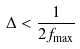<formula> <loc_0><loc_0><loc_500><loc_500>\Delta < \frac { 1 } { 2 f _ { \max } }</formula> 